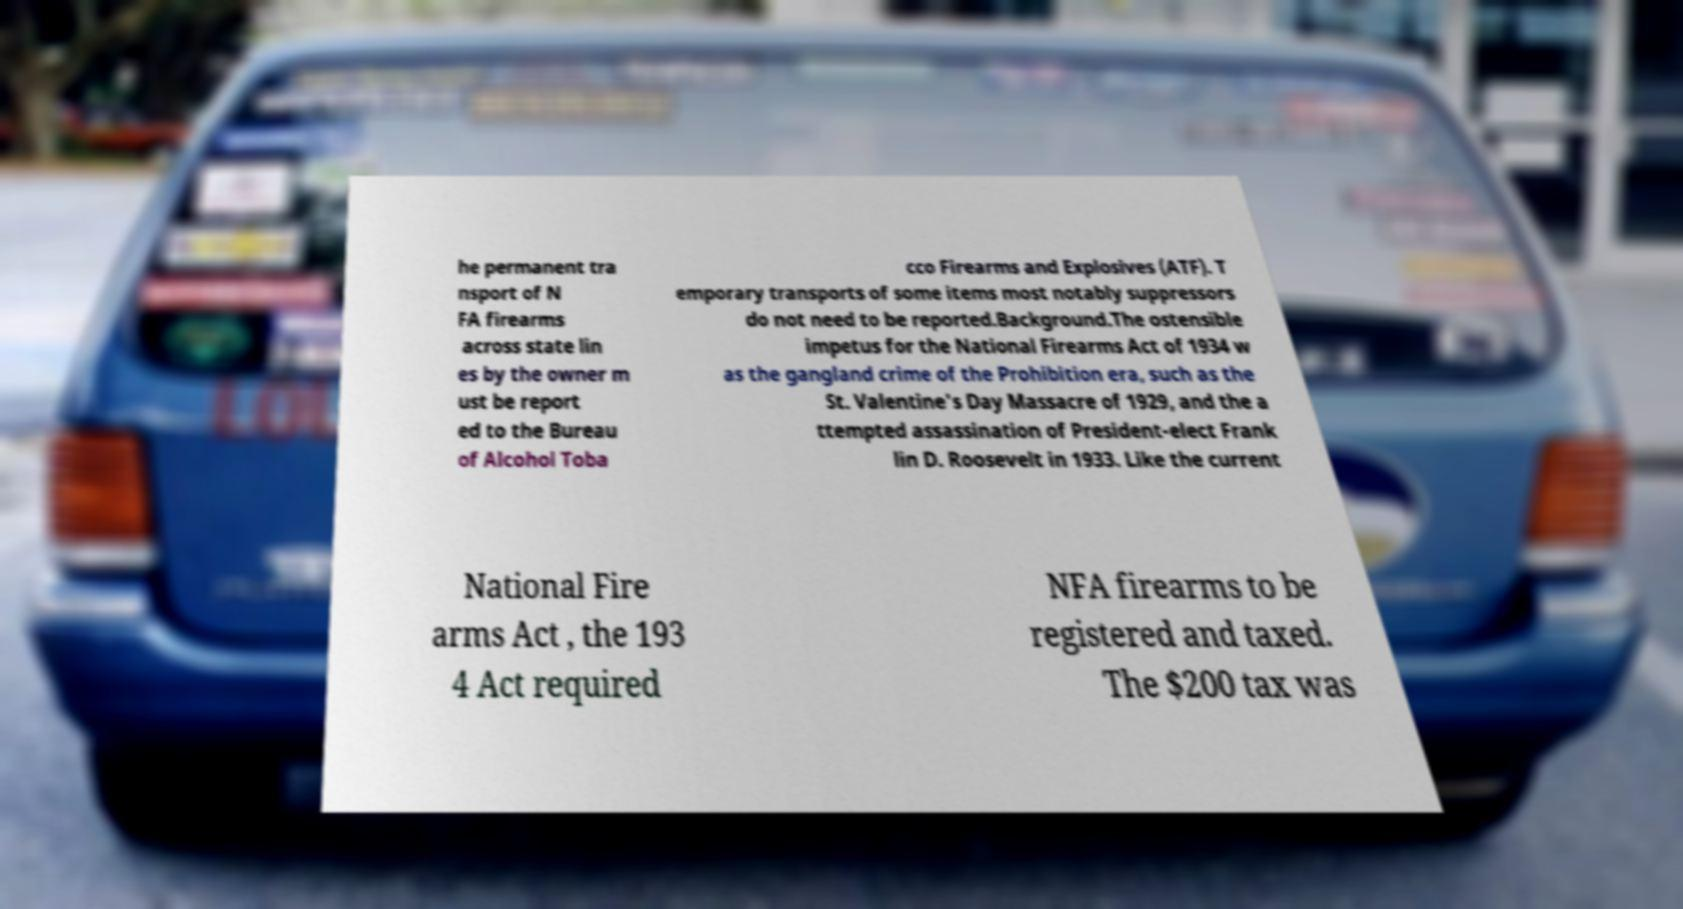What messages or text are displayed in this image? I need them in a readable, typed format. he permanent tra nsport of N FA firearms across state lin es by the owner m ust be report ed to the Bureau of Alcohol Toba cco Firearms and Explosives (ATF). T emporary transports of some items most notably suppressors do not need to be reported.Background.The ostensible impetus for the National Firearms Act of 1934 w as the gangland crime of the Prohibition era, such as the St. Valentine's Day Massacre of 1929, and the a ttempted assassination of President-elect Frank lin D. Roosevelt in 1933. Like the current National Fire arms Act , the 193 4 Act required NFA firearms to be registered and taxed. The $200 tax was 